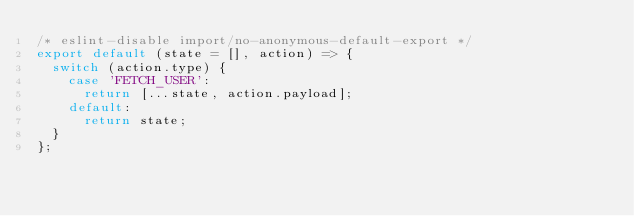Convert code to text. <code><loc_0><loc_0><loc_500><loc_500><_JavaScript_>/* eslint-disable import/no-anonymous-default-export */
export default (state = [], action) => {
  switch (action.type) {
    case 'FETCH_USER':
      return [...state, action.payload];
    default:
      return state;
  }
};
</code> 